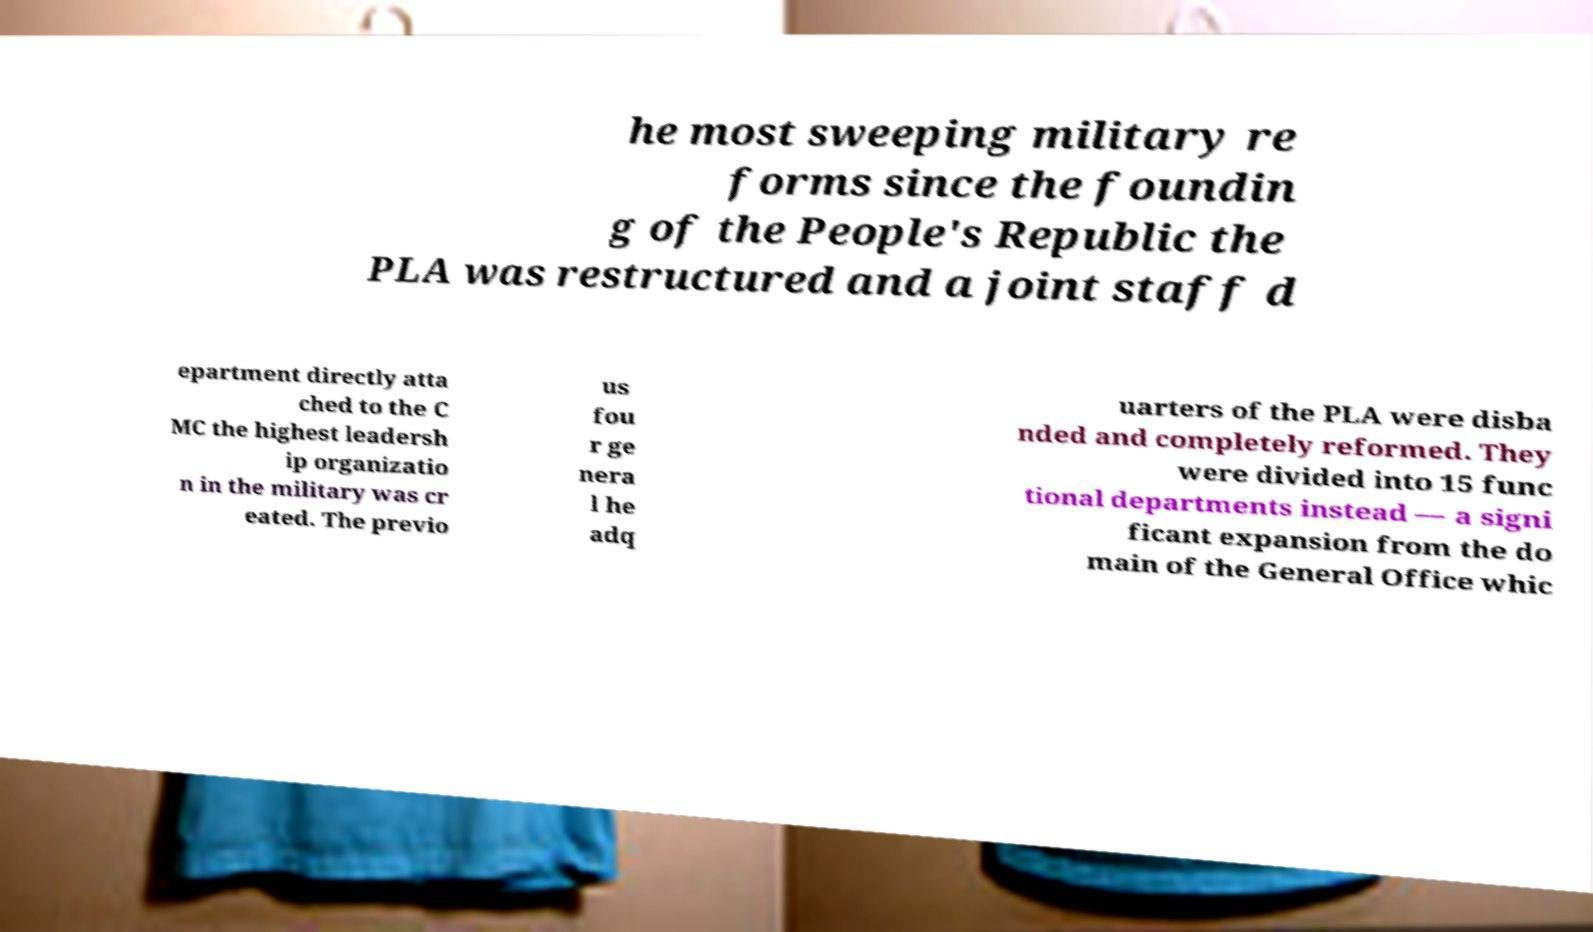Could you extract and type out the text from this image? he most sweeping military re forms since the foundin g of the People's Republic the PLA was restructured and a joint staff d epartment directly atta ched to the C MC the highest leadersh ip organizatio n in the military was cr eated. The previo us fou r ge nera l he adq uarters of the PLA were disba nded and completely reformed. They were divided into 15 func tional departments instead — a signi ficant expansion from the do main of the General Office whic 